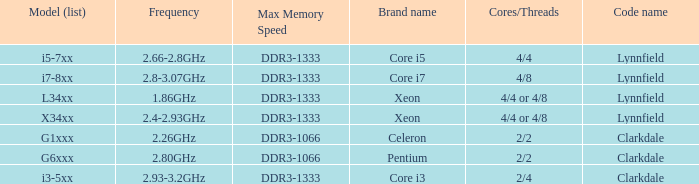What frequency does model L34xx use? 1.86GHz. 